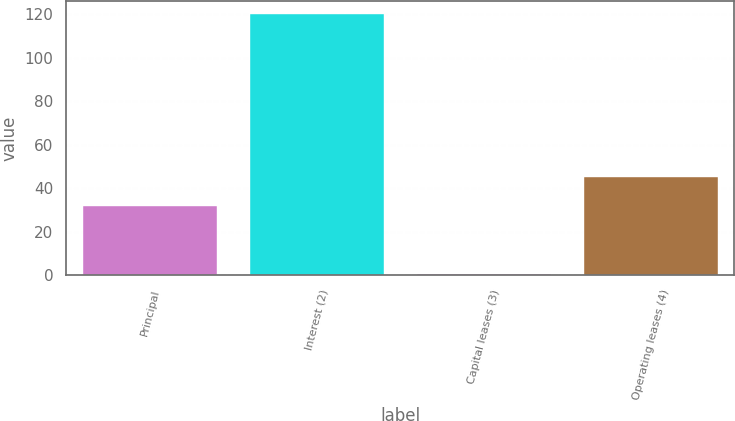Convert chart to OTSL. <chart><loc_0><loc_0><loc_500><loc_500><bar_chart><fcel>Principal<fcel>Interest (2)<fcel>Capital leases (3)<fcel>Operating leases (4)<nl><fcel>32<fcel>120.1<fcel>0.8<fcel>45.1<nl></chart> 